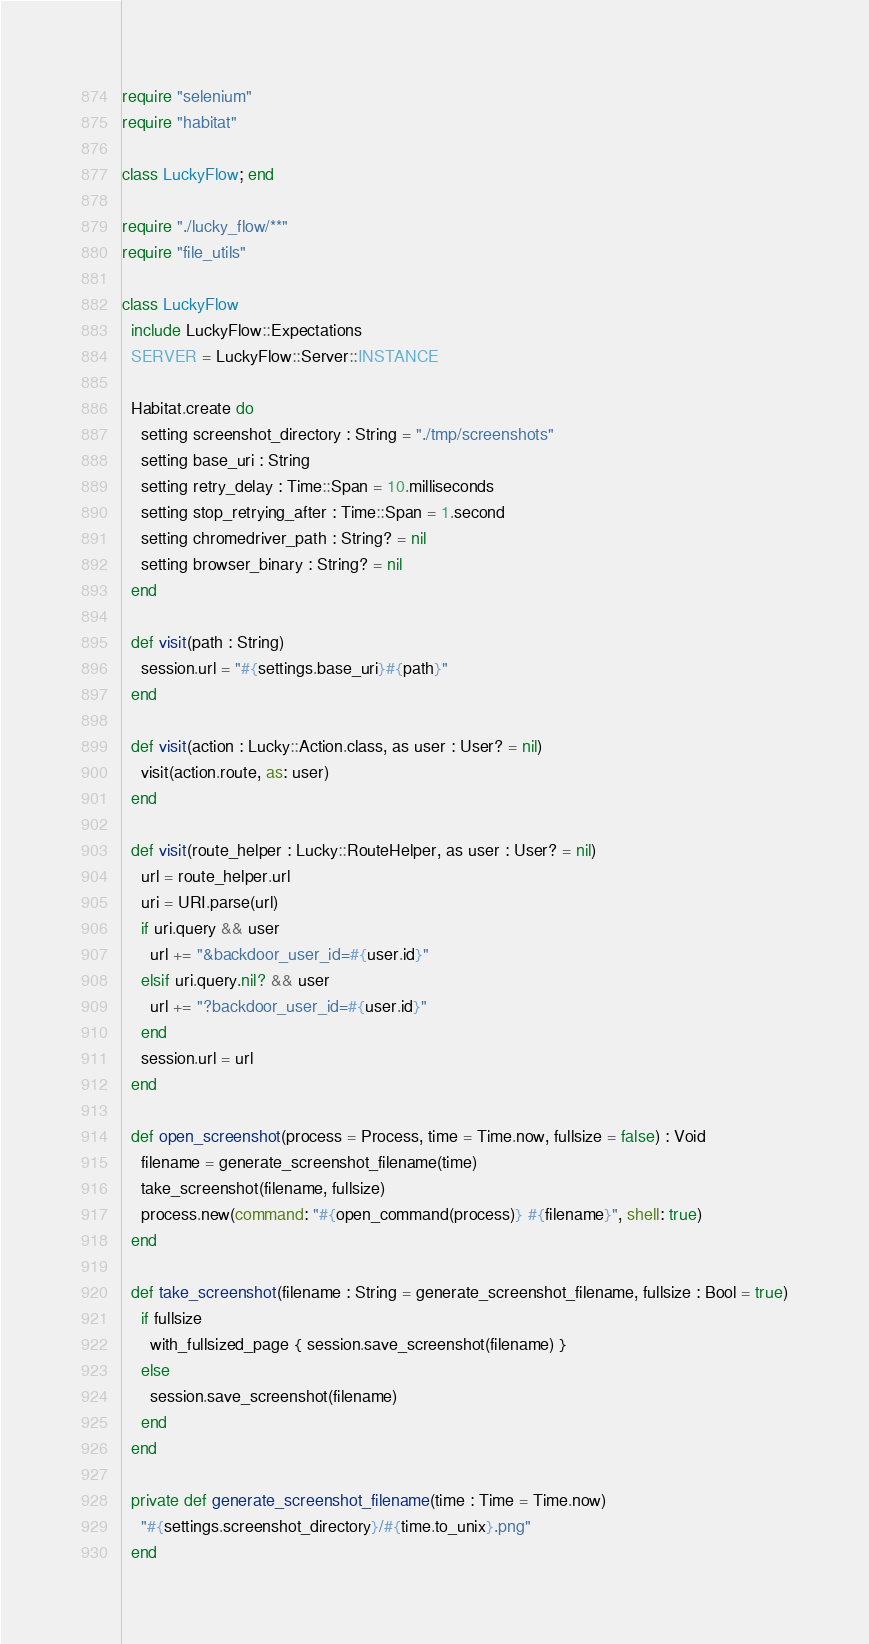<code> <loc_0><loc_0><loc_500><loc_500><_Crystal_>require "selenium"
require "habitat"

class LuckyFlow; end

require "./lucky_flow/**"
require "file_utils"

class LuckyFlow
  include LuckyFlow::Expectations
  SERVER = LuckyFlow::Server::INSTANCE

  Habitat.create do
    setting screenshot_directory : String = "./tmp/screenshots"
    setting base_uri : String
    setting retry_delay : Time::Span = 10.milliseconds
    setting stop_retrying_after : Time::Span = 1.second
    setting chromedriver_path : String? = nil
    setting browser_binary : String? = nil
  end

  def visit(path : String)
    session.url = "#{settings.base_uri}#{path}"
  end

  def visit(action : Lucky::Action.class, as user : User? = nil)
    visit(action.route, as: user)
  end

  def visit(route_helper : Lucky::RouteHelper, as user : User? = nil)
    url = route_helper.url
    uri = URI.parse(url)
    if uri.query && user
      url += "&backdoor_user_id=#{user.id}"
    elsif uri.query.nil? && user
      url += "?backdoor_user_id=#{user.id}"
    end
    session.url = url
  end

  def open_screenshot(process = Process, time = Time.now, fullsize = false) : Void
    filename = generate_screenshot_filename(time)
    take_screenshot(filename, fullsize)
    process.new(command: "#{open_command(process)} #{filename}", shell: true)
  end

  def take_screenshot(filename : String = generate_screenshot_filename, fullsize : Bool = true)
    if fullsize
      with_fullsized_page { session.save_screenshot(filename) }
    else
      session.save_screenshot(filename)
    end
  end

  private def generate_screenshot_filename(time : Time = Time.now)
    "#{settings.screenshot_directory}/#{time.to_unix}.png"
  end
</code> 